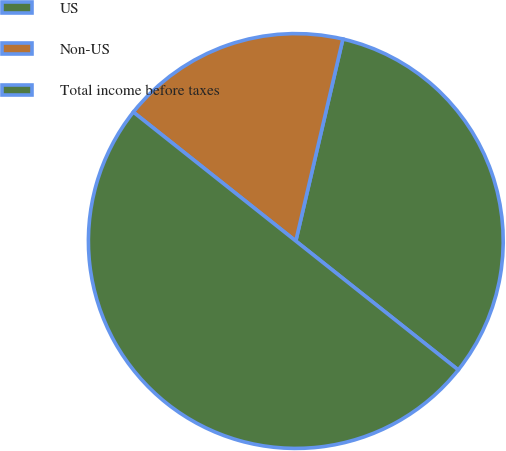Convert chart. <chart><loc_0><loc_0><loc_500><loc_500><pie_chart><fcel>US<fcel>Non-US<fcel>Total income before taxes<nl><fcel>32.03%<fcel>17.97%<fcel>50.0%<nl></chart> 